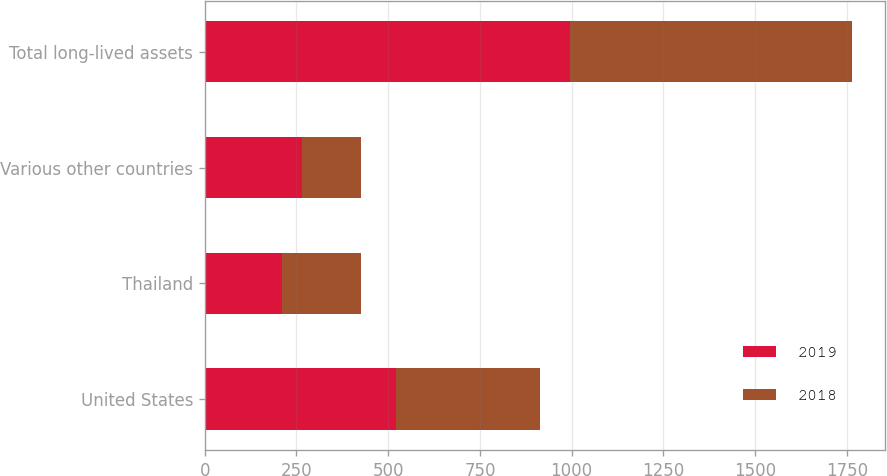<chart> <loc_0><loc_0><loc_500><loc_500><stacked_bar_chart><ecel><fcel>United States<fcel>Thailand<fcel>Various other countries<fcel>Total long-lived assets<nl><fcel>2019<fcel>521.1<fcel>209.3<fcel>266.3<fcel>996.7<nl><fcel>2018<fcel>393.3<fcel>215.5<fcel>159.1<fcel>767.9<nl></chart> 